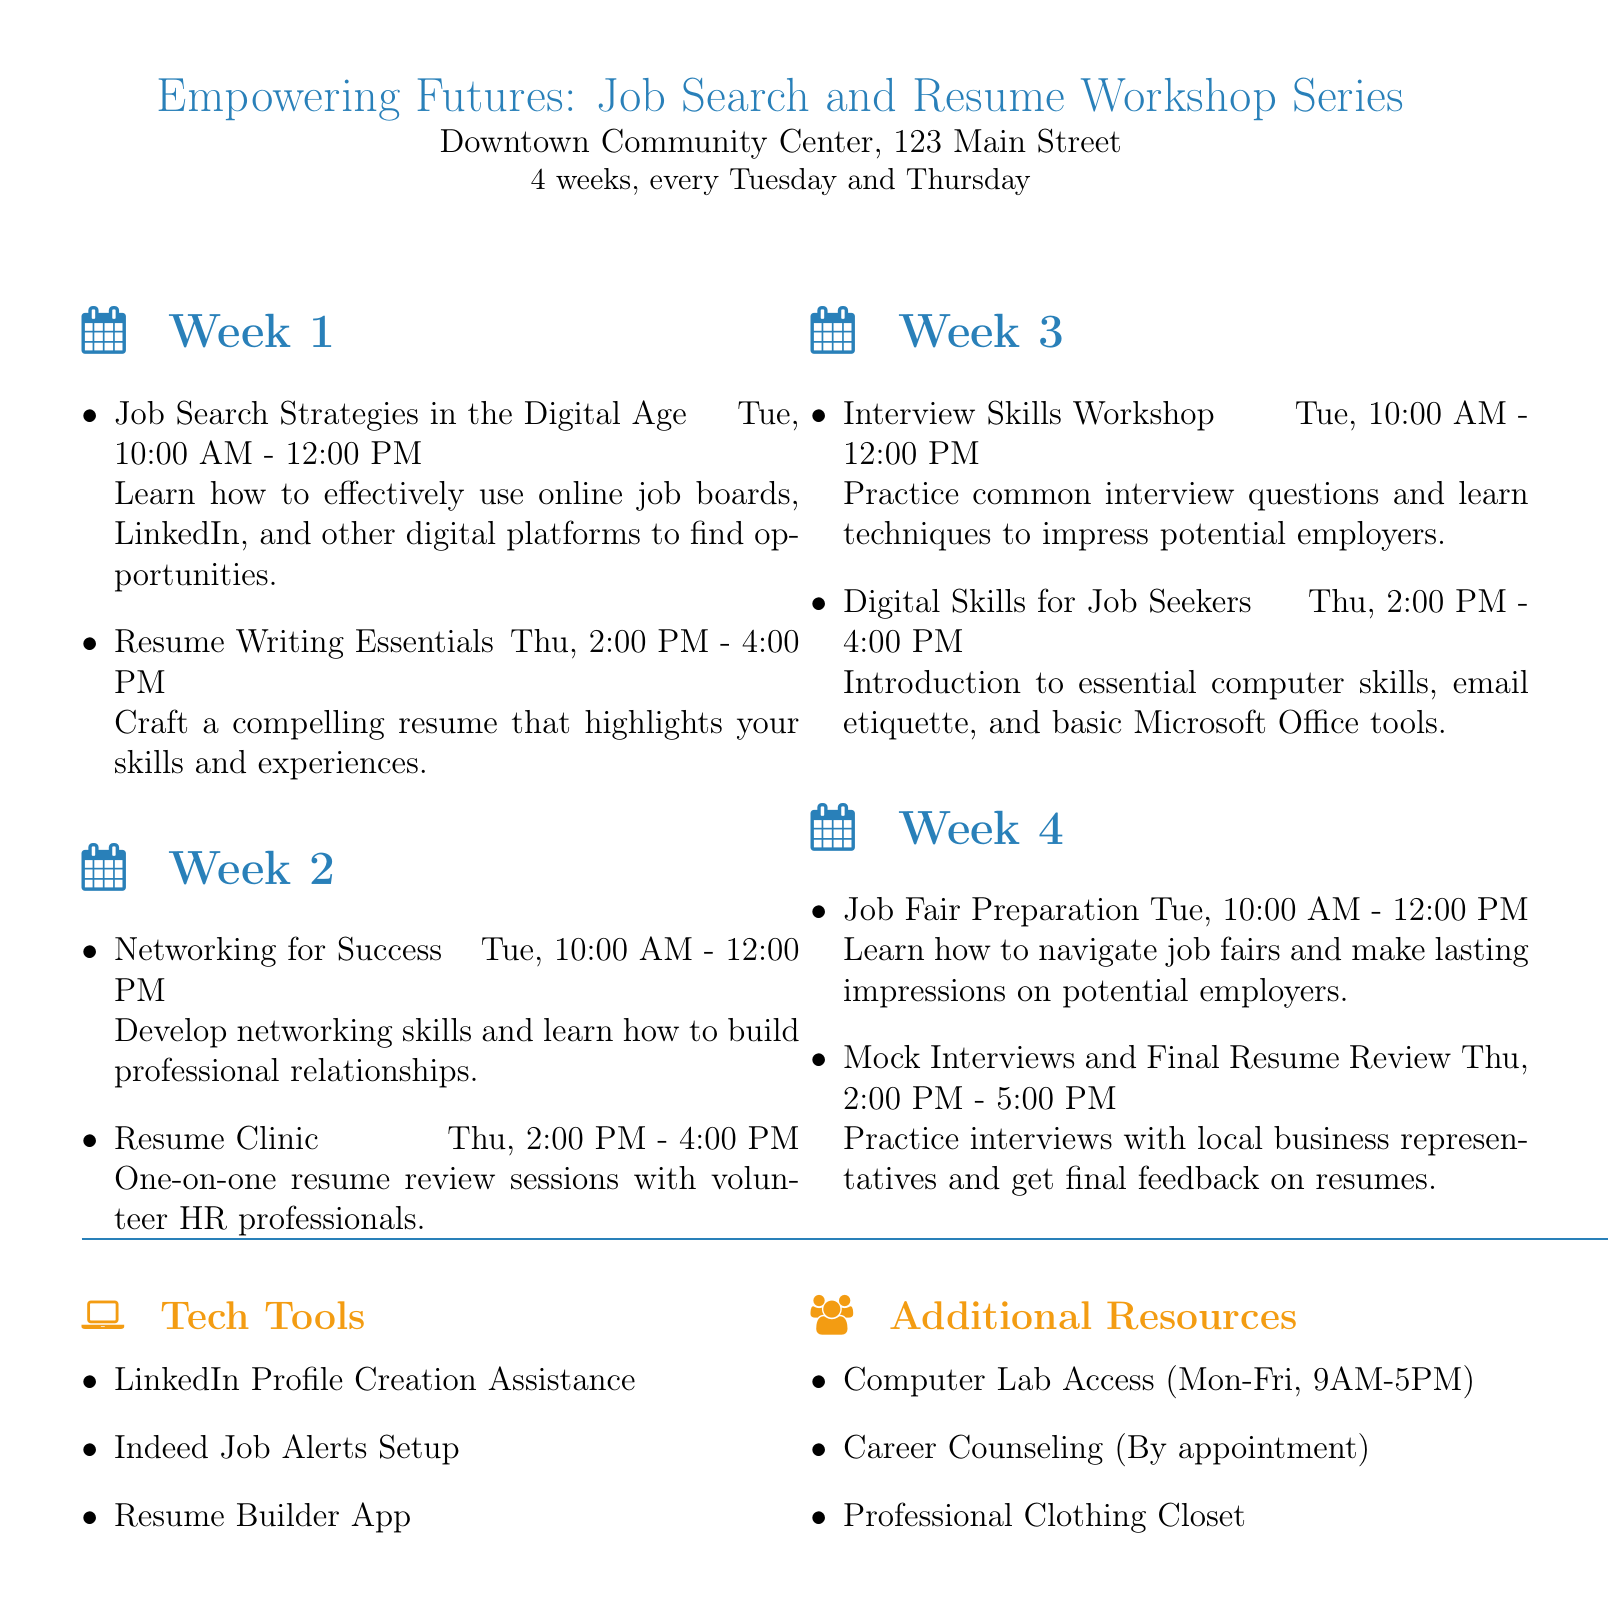what is the title of the workshop series? The title of the workshop series is listed at the top of the document.
Answer: Empowering Futures: Job Search and Resume Workshop Series where is the workshop being held? The location of the workshop is specified in the document.
Answer: Downtown Community Center, 123 Main Street how long is the workshop series? The duration of the workshop series is mentioned in the document.
Answer: 4 weeks, every Tuesday and Thursday who is the speaker for Week 1's Tuesday session? The speaker for the first Tuesday session is identified in the Week 1 schedule.
Answer: Sarah Chen what is the activity planned for the second Thursday? The activity scheduled for the second Thursday is stated in the document.
Answer: Resume Clinic which tech tool assists with LinkedIn profile creation? The tech tools section lists the available tools, including assistance for LinkedIn profiles.
Answer: LinkedIn Profile Creation Assistance what time does the Mock Interviews session begin? The start time of the Mock Interviews session is included in the Week 4 schedule.
Answer: 2:00 PM how many facilitators are involved in the Resume Clinic? The number of facilitators can be counted from the document under the Resume Clinic section.
Answer: 3 facilitators what additional resource is available during workshop hours? The additional resource available during workshop hours is specified in the resources section.
Answer: Professional Clothing Closet 